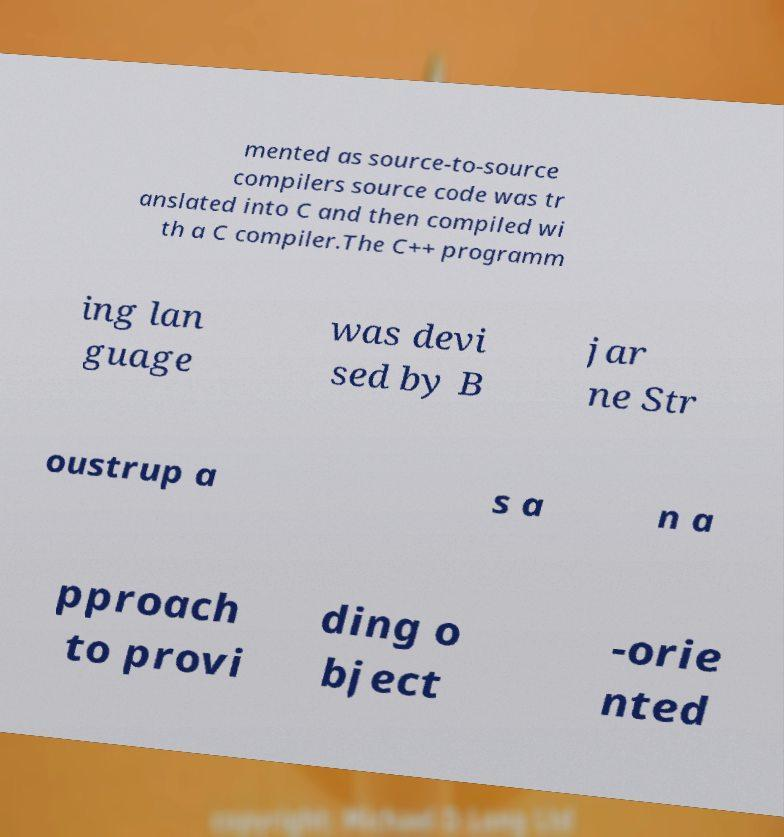Can you read and provide the text displayed in the image?This photo seems to have some interesting text. Can you extract and type it out for me? mented as source-to-source compilers source code was tr anslated into C and then compiled wi th a C compiler.The C++ programm ing lan guage was devi sed by B jar ne Str oustrup a s a n a pproach to provi ding o bject -orie nted 